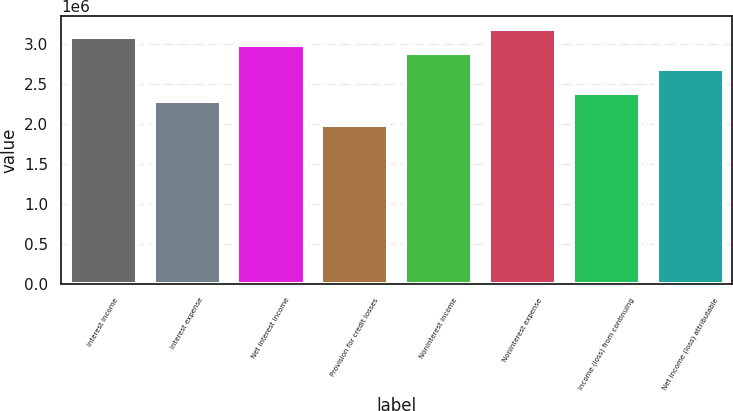Convert chart. <chart><loc_0><loc_0><loc_500><loc_500><bar_chart><fcel>Interest income<fcel>Interest expense<fcel>Net interest income<fcel>Provision for credit losses<fcel>Noninterest income<fcel>Noninterest expense<fcel>Income (loss) from continuing<fcel>Net income (loss) attributable<nl><fcel>3.08345e+06<fcel>2.28772e+06<fcel>2.98398e+06<fcel>1.98932e+06<fcel>2.88451e+06<fcel>3.18291e+06<fcel>2.38718e+06<fcel>2.68558e+06<nl></chart> 